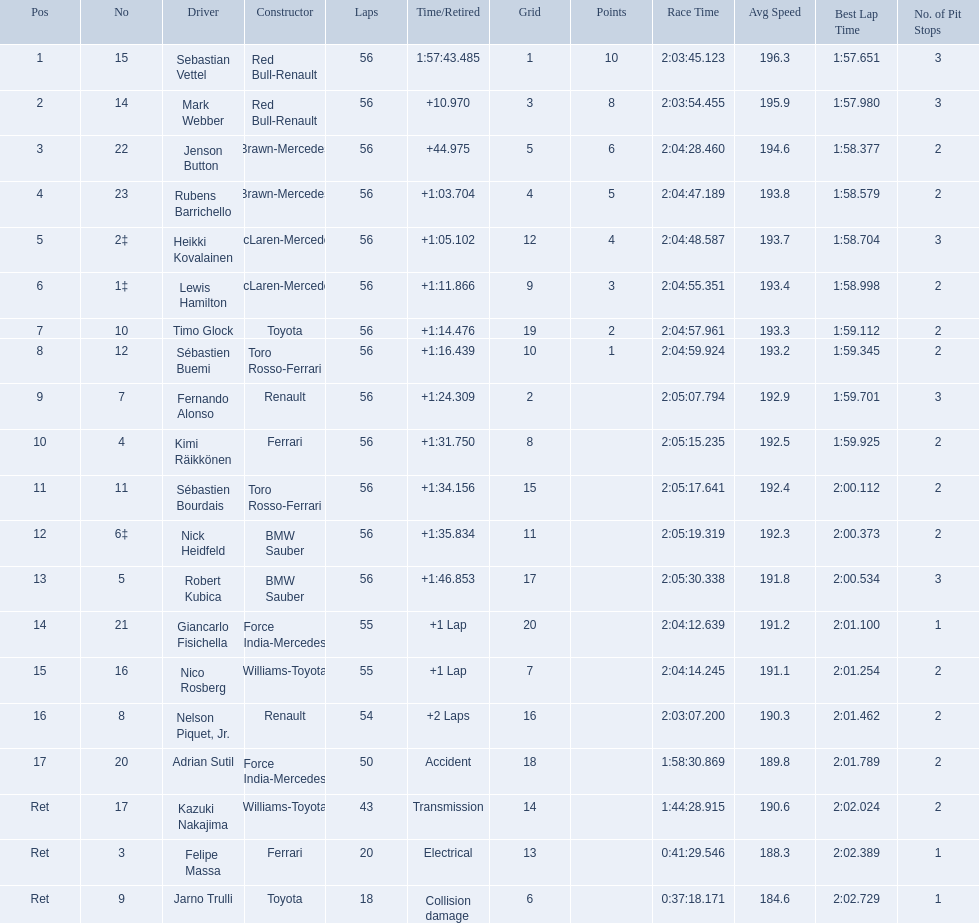Who were all the drivers? Sebastian Vettel, Mark Webber, Jenson Button, Rubens Barrichello, Heikki Kovalainen, Lewis Hamilton, Timo Glock, Sébastien Buemi, Fernando Alonso, Kimi Räikkönen, Sébastien Bourdais, Nick Heidfeld, Robert Kubica, Giancarlo Fisichella, Nico Rosberg, Nelson Piquet, Jr., Adrian Sutil, Kazuki Nakajima, Felipe Massa, Jarno Trulli. Which of these didn't have ferrari as a constructor? Sebastian Vettel, Mark Webber, Jenson Button, Rubens Barrichello, Heikki Kovalainen, Lewis Hamilton, Timo Glock, Sébastien Buemi, Fernando Alonso, Sébastien Bourdais, Nick Heidfeld, Robert Kubica, Giancarlo Fisichella, Nico Rosberg, Nelson Piquet, Jr., Adrian Sutil, Kazuki Nakajima, Jarno Trulli. Which of these was in first place? Sebastian Vettel. 